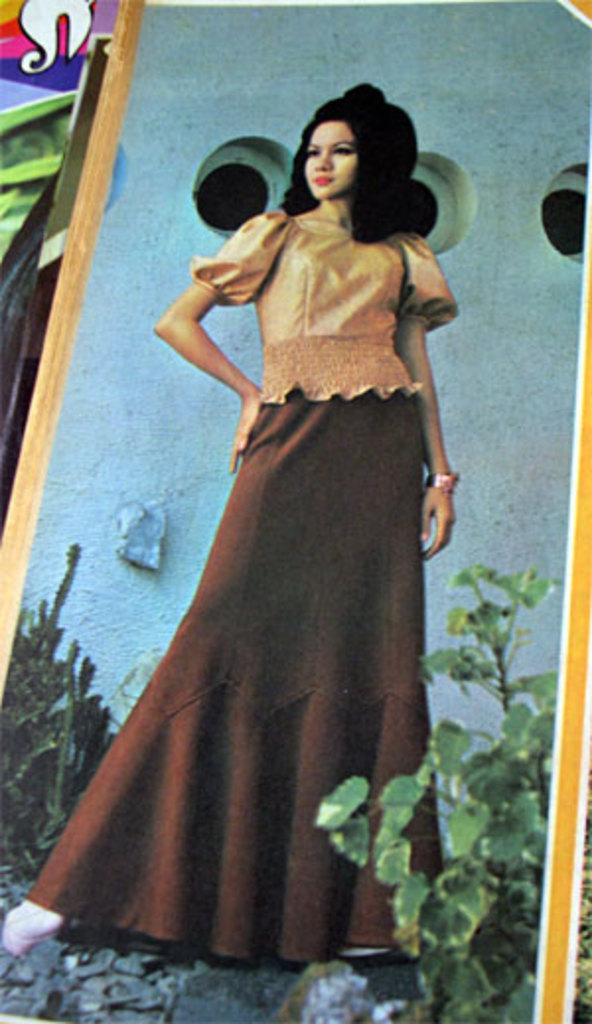What is the main subject of the photo in the image? There is a photo of a woman standing in the image. What can be seen in the background of the photo? There are plants and a wall visible in the photo. Are there any other objects or features in the photo besides the woman and the background? Yes, there are items visible in the background of the photo. What type of harmony is the woman singing in the photo? There is no indication in the photo that the woman is singing or that there is any harmony present. 